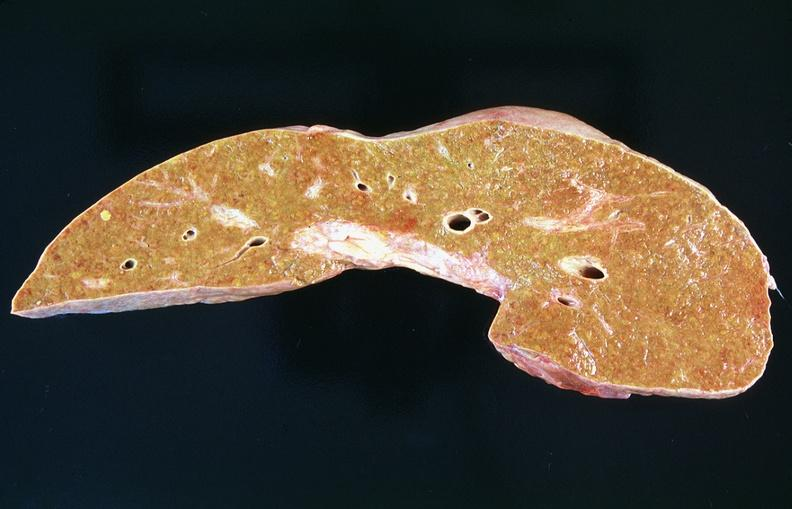s hepatobiliary present?
Answer the question using a single word or phrase. Yes 